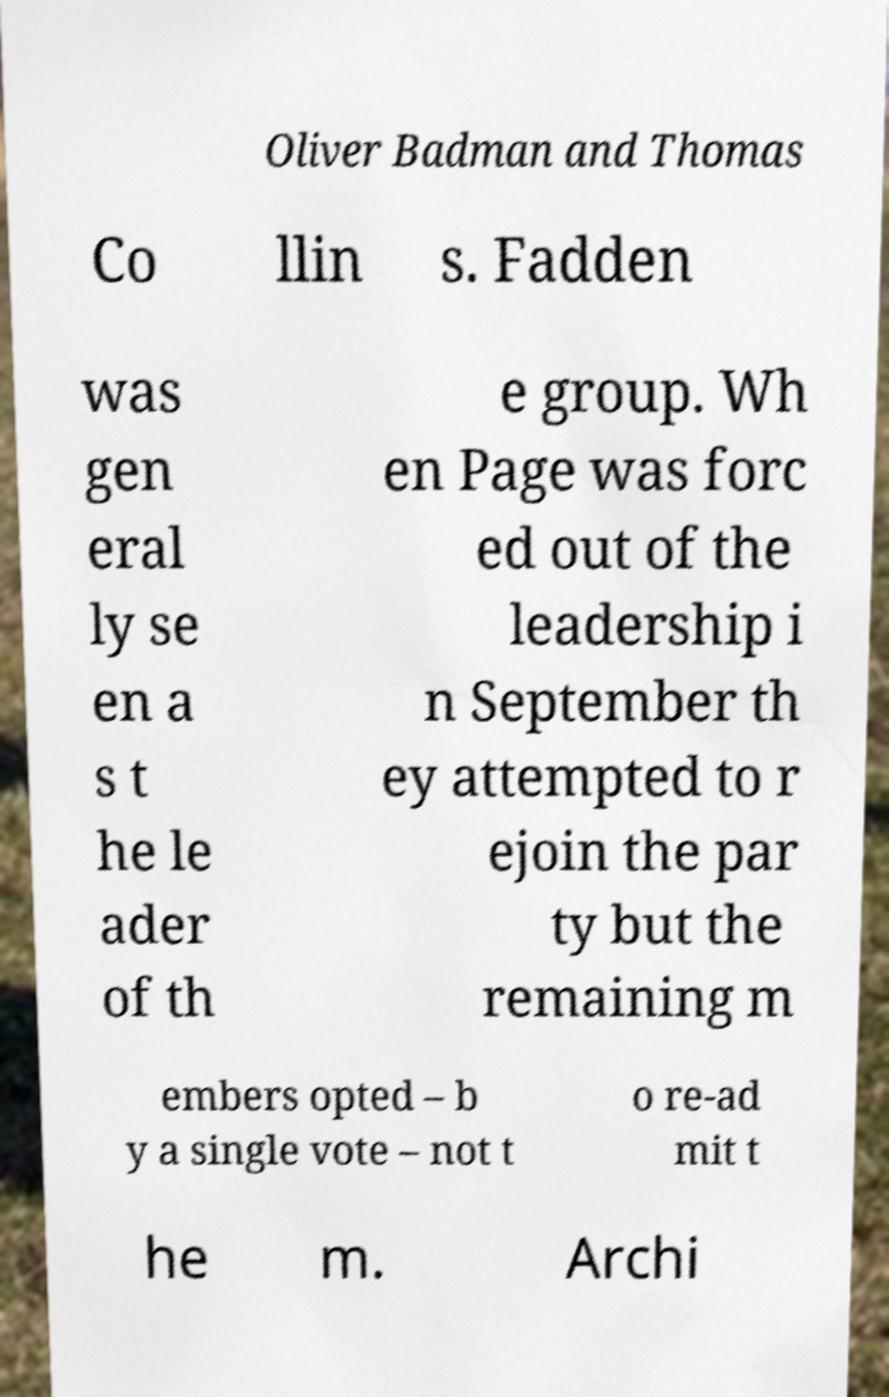Please identify and transcribe the text found in this image. Oliver Badman and Thomas Co llin s. Fadden was gen eral ly se en a s t he le ader of th e group. Wh en Page was forc ed out of the leadership i n September th ey attempted to r ejoin the par ty but the remaining m embers opted – b y a single vote – not t o re-ad mit t he m. Archi 